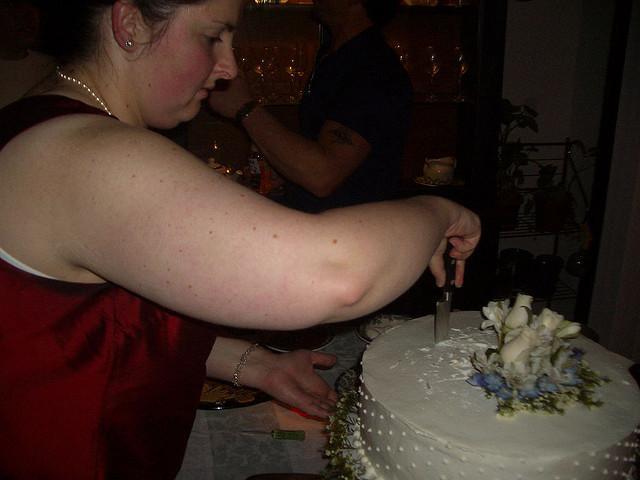How many people are there?
Give a very brief answer. 2. 